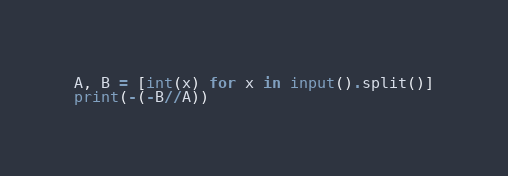Convert code to text. <code><loc_0><loc_0><loc_500><loc_500><_Python_>A, B = [int(x) for x in input().split()]
print(-(-B//A))
</code> 